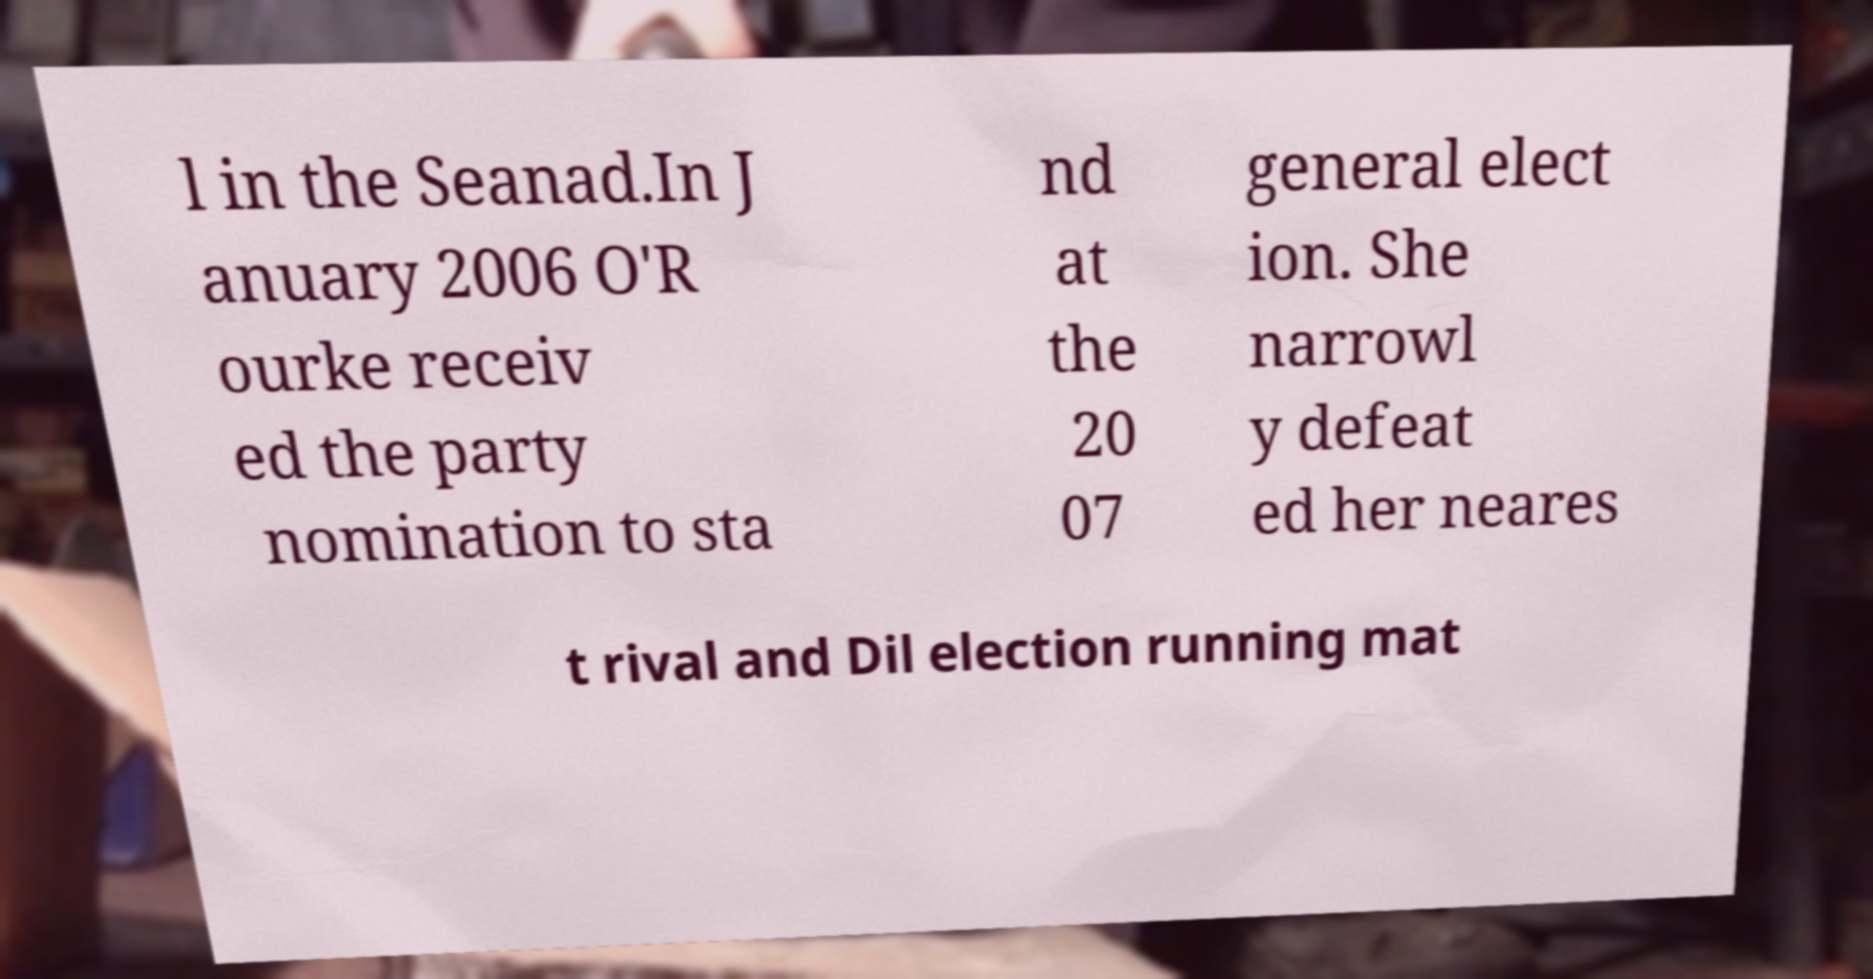I need the written content from this picture converted into text. Can you do that? l in the Seanad.In J anuary 2006 O'R ourke receiv ed the party nomination to sta nd at the 20 07 general elect ion. She narrowl y defeat ed her neares t rival and Dil election running mat 